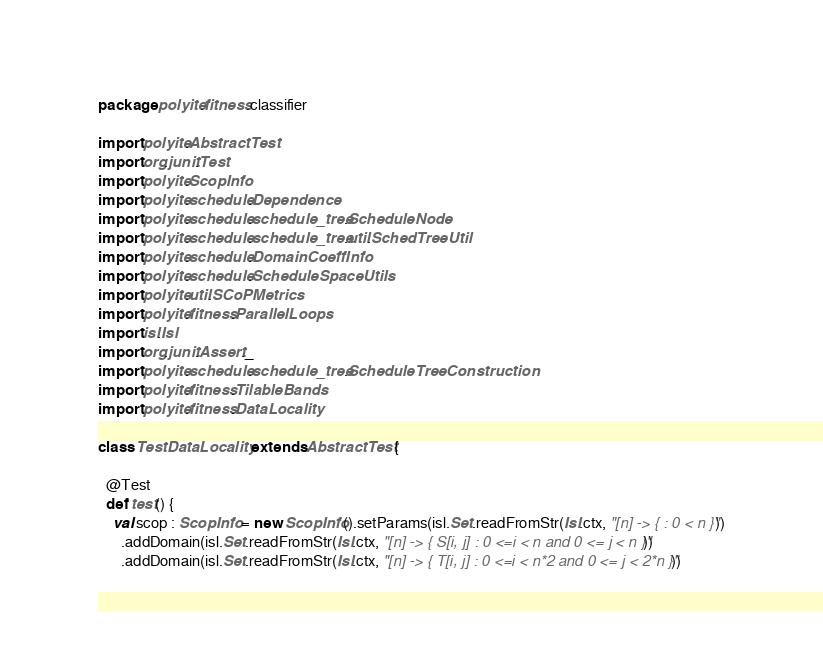<code> <loc_0><loc_0><loc_500><loc_500><_Scala_>package polyite.fitness.classifier

import polyite.AbstractTest
import org.junit.Test
import polyite.ScopInfo
import polyite.schedule.Dependence
import polyite.schedule.schedule_tree.ScheduleNode
import polyite.schedule.schedule_tree.util.SchedTreeUtil
import polyite.schedule.DomainCoeffInfo
import polyite.schedule.ScheduleSpaceUtils
import polyite.util.SCoPMetrics
import polyite.fitness.ParallelLoops
import isl.Isl
import org.junit.Assert._
import polyite.schedule.schedule_tree.ScheduleTreeConstruction
import polyite.fitness.TilableBands
import polyite.fitness.DataLocality

class TestDataLocality extends AbstractTest {
  
  @Test
  def test() {
    val scop : ScopInfo = new ScopInfo().setParams(isl.Set.readFromStr(Isl.ctx, "[n] -> { : 0 < n }"))
      .addDomain(isl.Set.readFromStr(Isl.ctx, "[n] -> { S[i, j] : 0 <=i < n and 0 <= j < n }"))
      .addDomain(isl.Set.readFromStr(Isl.ctx, "[n] -> { T[i, j] : 0 <=i < n*2 and 0 <= j < 2*n }"))</code> 